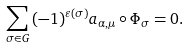Convert formula to latex. <formula><loc_0><loc_0><loc_500><loc_500>\sum _ { \sigma \in G } { ( - 1 ) ^ { \varepsilon ( { \sigma } ) } a _ { \alpha , \mu } \circ \Phi _ { \sigma } } = 0 .</formula> 